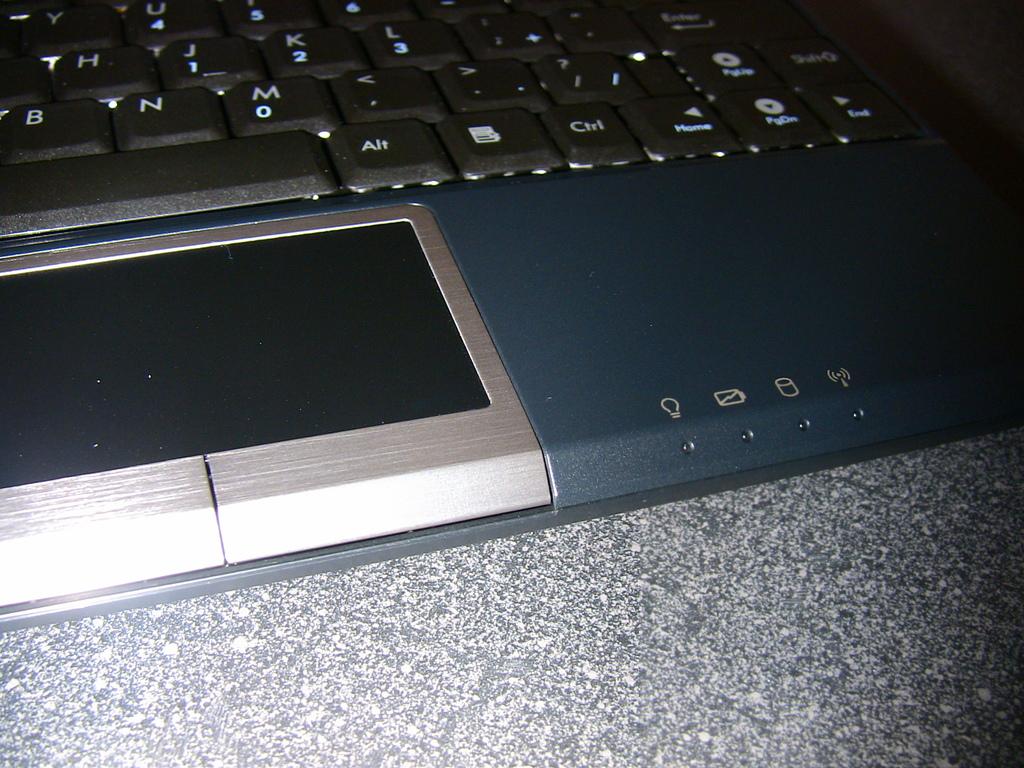What key is next to the spacebar?
Ensure brevity in your answer.  Alt. What letter key is to the left of the m?
Give a very brief answer. N. 